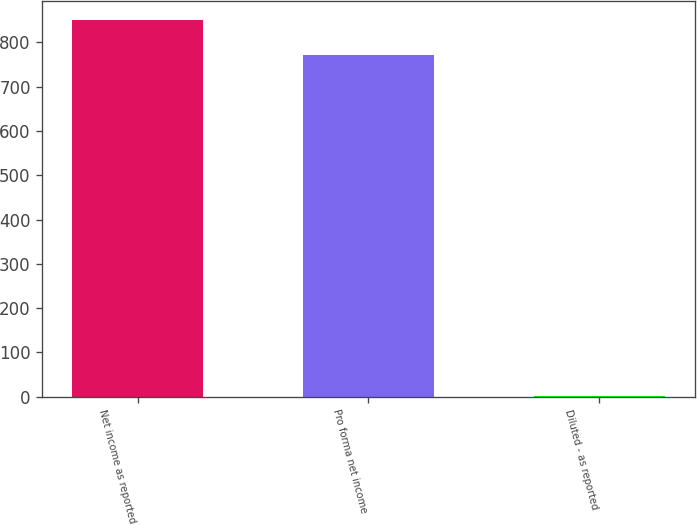<chart> <loc_0><loc_0><loc_500><loc_500><bar_chart><fcel>Net income as reported<fcel>Pro forma net income<fcel>Diluted - as reported<nl><fcel>850.57<fcel>771<fcel>2.35<nl></chart> 